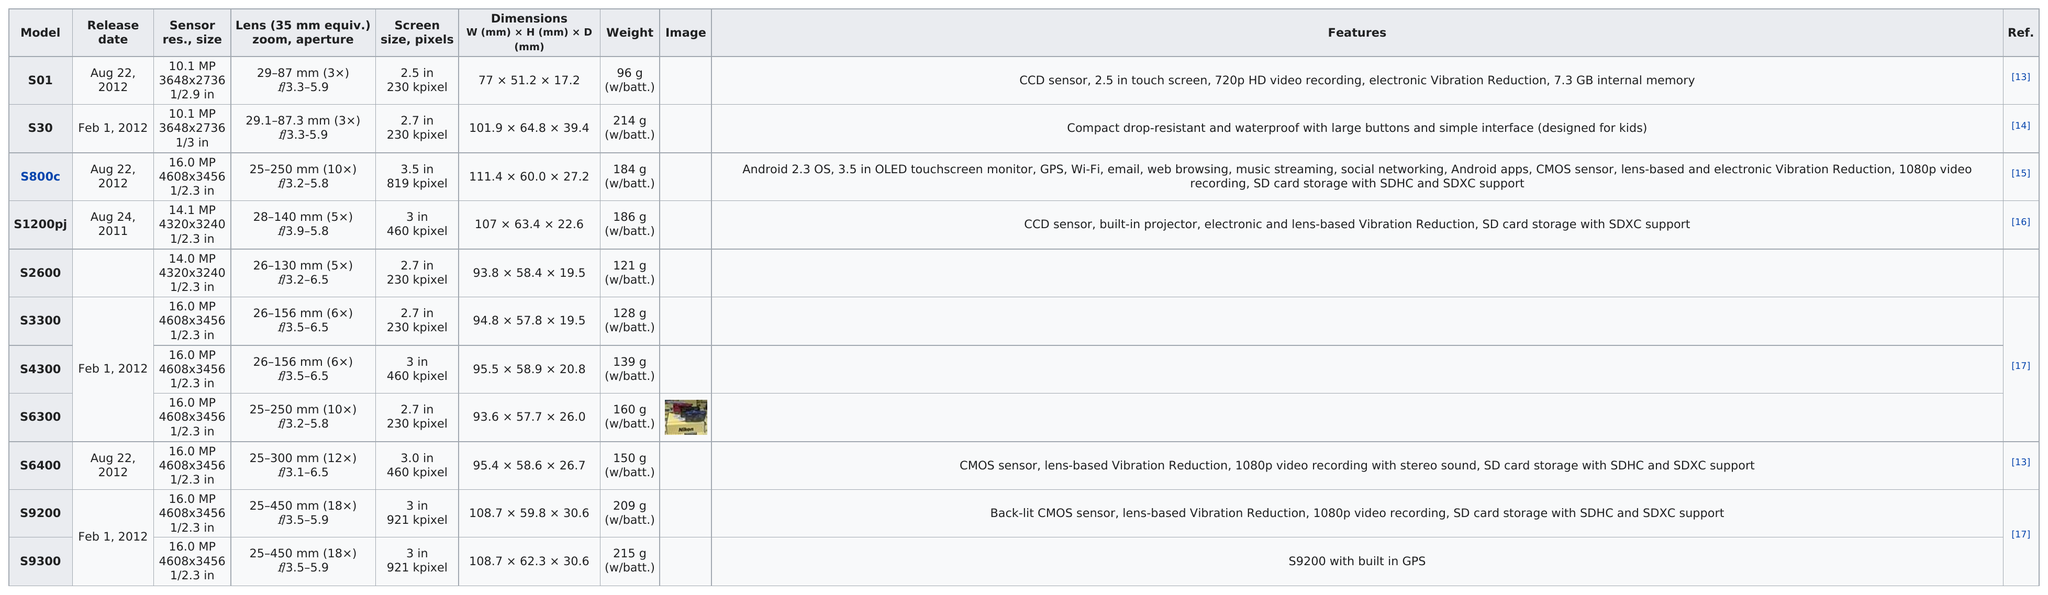Outline some significant characteristics in this image. The S800c model has the largest screen size among all models. Another product with a 2.7-inch screen, other than the S3300, that I am able to recommend is the S30. There are 10 items that have a weight exceeding 120 grams. It is uncertain which model weighs the most between S9300... In 2012, 9 were released. 